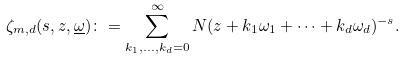Convert formula to latex. <formula><loc_0><loc_0><loc_500><loc_500>\zeta _ { m , d } ( s , z , \underline { \omega } ) \colon = \sum _ { k _ { 1 } , \dots , k _ { d } = 0 } ^ { \infty } N ( z + k _ { 1 } \omega _ { 1 } + \cdots + k _ { d } \omega _ { d } ) ^ { - s } .</formula> 